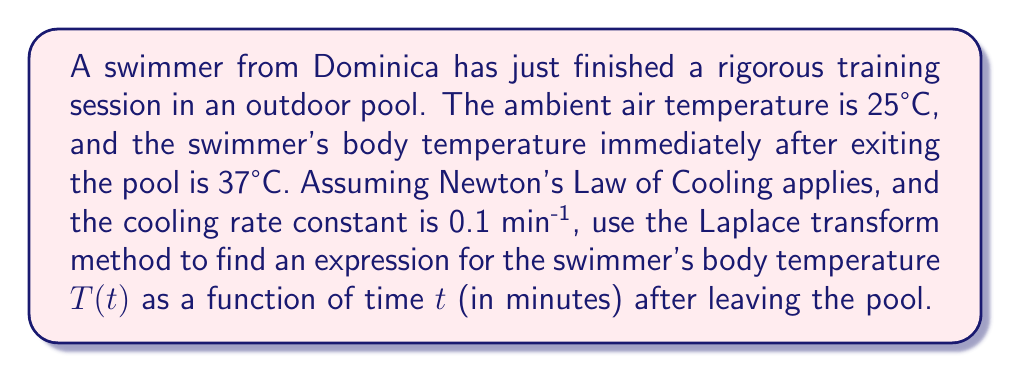Can you solve this math problem? Let's approach this step-by-step using the Laplace transform method:

1) Newton's Law of Cooling states that the rate of change of temperature is proportional to the difference between the object's temperature and the ambient temperature:

   $$\frac{dT}{dt} = -k(T - T_a)$$

   where $k$ is the cooling rate constant, $T$ is the object's temperature, and $T_a$ is the ambient temperature.

2) We can rewrite this as:

   $$\frac{dT}{dt} + kT = kT_a$$

3) With initial condition $T(0) = 37°C$, ambient temperature $T_a = 25°C$, and $k = 0.1$ min^(-1), our problem becomes:

   $$\frac{dT}{dt} + 0.1T = 2.5$$
   $$T(0) = 37$$

4) Taking the Laplace transform of both sides:

   $$\mathcal{L}\{\frac{dT}{dt}\} + 0.1\mathcal{L}\{T\} = \frac{2.5}{s}$$

5) Using the Laplace transform properties:

   $$s\mathcal{L}\{T\} - T(0) + 0.1\mathcal{L}\{T\} = \frac{2.5}{s}$$

6) Substituting $T(0) = 37$:

   $$s\mathcal{L}\{T\} - 37 + 0.1\mathcal{L}\{T\} = \frac{2.5}{s}$$

7) Factoring out $\mathcal{L}\{T\}$:

   $$(s + 0.1)\mathcal{L}\{T\} = \frac{2.5}{s} + 37$$

8) Solving for $\mathcal{L}\{T\}$:

   $$\mathcal{L}\{T\} = \frac{2.5}{s(s + 0.1)} + \frac{37}{s + 0.1}$$

9) Using partial fraction decomposition:

   $$\mathcal{L}\{T\} = \frac{25}{s} - \frac{25}{s + 0.1} + \frac{37}{s + 0.1} = \frac{25}{s} + \frac{12}{s + 0.1}$$

10) Taking the inverse Laplace transform:

    $$T(t) = 25 + 12e^{-0.1t}$$

This is the expression for the swimmer's body temperature as a function of time after leaving the pool.
Answer: $T(t) = 25 + 12e^{-0.1t}$, where $T$ is in °C and $t$ is in minutes. 